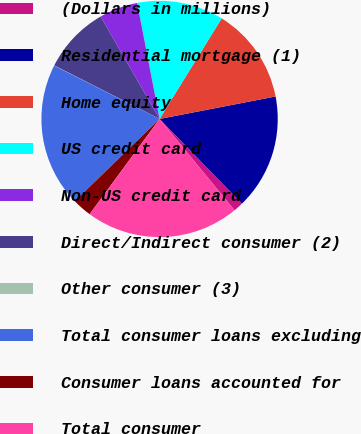Convert chart. <chart><loc_0><loc_0><loc_500><loc_500><pie_chart><fcel>(Dollars in millions)<fcel>Residential mortgage (1)<fcel>Home equity<fcel>US credit card<fcel>Non-US credit card<fcel>Direct/Indirect consumer (2)<fcel>Other consumer (3)<fcel>Total consumer loans excluding<fcel>Consumer loans accounted for<fcel>Total consumer<nl><fcel>1.34%<fcel>15.77%<fcel>13.15%<fcel>11.84%<fcel>5.28%<fcel>9.21%<fcel>0.03%<fcel>19.71%<fcel>2.65%<fcel>21.02%<nl></chart> 